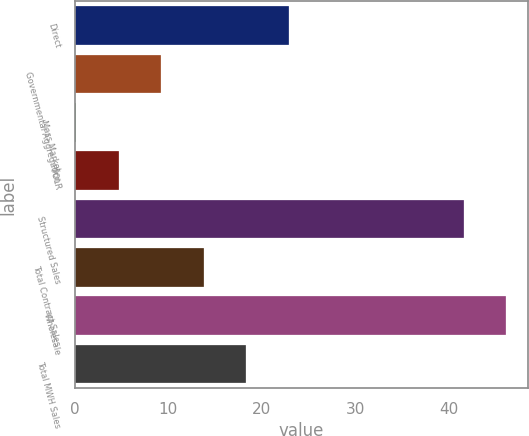Convert chart to OTSL. <chart><loc_0><loc_0><loc_500><loc_500><bar_chart><fcel>Direct<fcel>Governmental Aggregation<fcel>Mass Market<fcel>POLR<fcel>Structured Sales<fcel>Total Contract Sales<fcel>Wholesale<fcel>Total MWH Sales<nl><fcel>22.9<fcel>9.28<fcel>0.2<fcel>4.74<fcel>41.6<fcel>13.82<fcel>46.14<fcel>18.36<nl></chart> 